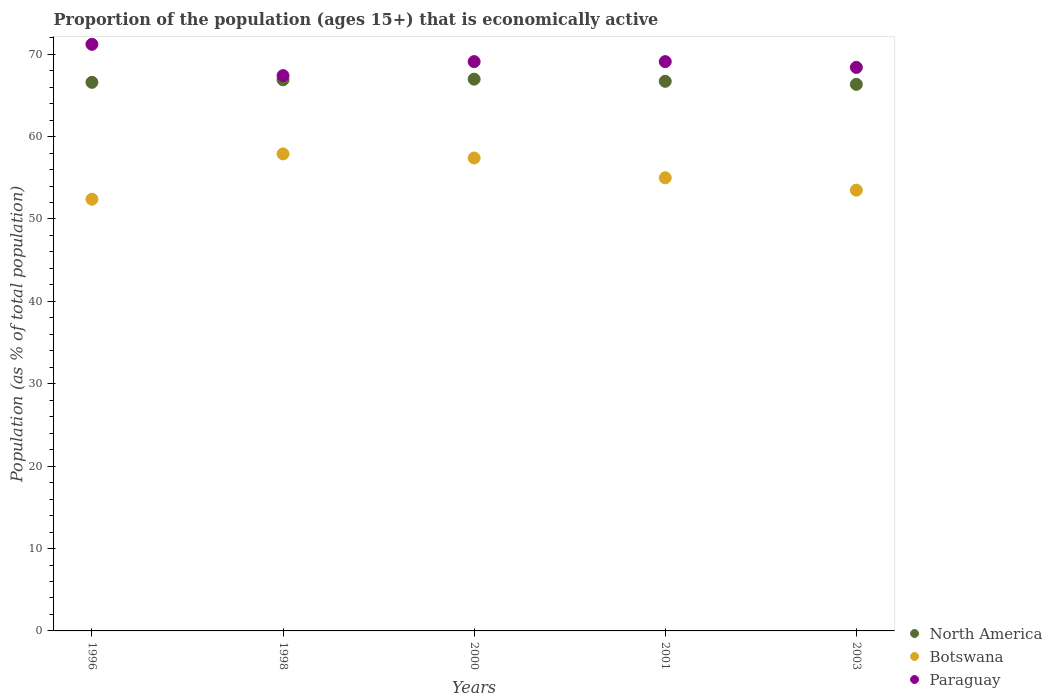What is the proportion of the population that is economically active in Paraguay in 2003?
Make the answer very short. 68.4. Across all years, what is the maximum proportion of the population that is economically active in North America?
Your answer should be very brief. 66.97. Across all years, what is the minimum proportion of the population that is economically active in North America?
Your answer should be compact. 66.34. What is the total proportion of the population that is economically active in Paraguay in the graph?
Offer a very short reply. 345.2. What is the difference between the proportion of the population that is economically active in North America in 1996 and that in 2003?
Offer a terse response. 0.25. What is the difference between the proportion of the population that is economically active in North America in 1998 and the proportion of the population that is economically active in Paraguay in 2003?
Provide a short and direct response. -1.5. What is the average proportion of the population that is economically active in Paraguay per year?
Provide a succinct answer. 69.04. In the year 2003, what is the difference between the proportion of the population that is economically active in Botswana and proportion of the population that is economically active in North America?
Ensure brevity in your answer.  -12.84. In how many years, is the proportion of the population that is economically active in Paraguay greater than 12 %?
Your response must be concise. 5. What is the ratio of the proportion of the population that is economically active in Paraguay in 1998 to that in 2003?
Your answer should be very brief. 0.99. Is the difference between the proportion of the population that is economically active in Botswana in 2001 and 2003 greater than the difference between the proportion of the population that is economically active in North America in 2001 and 2003?
Provide a short and direct response. Yes. What is the difference between the highest and the second highest proportion of the population that is economically active in Botswana?
Provide a short and direct response. 0.5. What is the difference between the highest and the lowest proportion of the population that is economically active in North America?
Provide a succinct answer. 0.63. In how many years, is the proportion of the population that is economically active in Paraguay greater than the average proportion of the population that is economically active in Paraguay taken over all years?
Offer a terse response. 3. Is the sum of the proportion of the population that is economically active in Paraguay in 1998 and 2003 greater than the maximum proportion of the population that is economically active in Botswana across all years?
Your answer should be very brief. Yes. Is it the case that in every year, the sum of the proportion of the population that is economically active in North America and proportion of the population that is economically active in Paraguay  is greater than the proportion of the population that is economically active in Botswana?
Provide a short and direct response. Yes. Does the proportion of the population that is economically active in Botswana monotonically increase over the years?
Your answer should be very brief. No. How many dotlines are there?
Your response must be concise. 3. How many years are there in the graph?
Your answer should be compact. 5. What is the difference between two consecutive major ticks on the Y-axis?
Your answer should be compact. 10. Are the values on the major ticks of Y-axis written in scientific E-notation?
Your response must be concise. No. Does the graph contain any zero values?
Make the answer very short. No. How many legend labels are there?
Offer a very short reply. 3. How are the legend labels stacked?
Your answer should be compact. Vertical. What is the title of the graph?
Ensure brevity in your answer.  Proportion of the population (ages 15+) that is economically active. Does "Mexico" appear as one of the legend labels in the graph?
Keep it short and to the point. No. What is the label or title of the X-axis?
Provide a succinct answer. Years. What is the label or title of the Y-axis?
Ensure brevity in your answer.  Population (as % of total population). What is the Population (as % of total population) in North America in 1996?
Keep it short and to the point. 66.59. What is the Population (as % of total population) of Botswana in 1996?
Provide a short and direct response. 52.4. What is the Population (as % of total population) in Paraguay in 1996?
Your answer should be very brief. 71.2. What is the Population (as % of total population) in North America in 1998?
Provide a succinct answer. 66.9. What is the Population (as % of total population) in Botswana in 1998?
Make the answer very short. 57.9. What is the Population (as % of total population) of Paraguay in 1998?
Make the answer very short. 67.4. What is the Population (as % of total population) in North America in 2000?
Your answer should be compact. 66.97. What is the Population (as % of total population) of Botswana in 2000?
Offer a very short reply. 57.4. What is the Population (as % of total population) in Paraguay in 2000?
Give a very brief answer. 69.1. What is the Population (as % of total population) of North America in 2001?
Make the answer very short. 66.71. What is the Population (as % of total population) in Botswana in 2001?
Your response must be concise. 55. What is the Population (as % of total population) in Paraguay in 2001?
Ensure brevity in your answer.  69.1. What is the Population (as % of total population) in North America in 2003?
Give a very brief answer. 66.34. What is the Population (as % of total population) of Botswana in 2003?
Make the answer very short. 53.5. What is the Population (as % of total population) in Paraguay in 2003?
Offer a very short reply. 68.4. Across all years, what is the maximum Population (as % of total population) of North America?
Provide a short and direct response. 66.97. Across all years, what is the maximum Population (as % of total population) in Botswana?
Ensure brevity in your answer.  57.9. Across all years, what is the maximum Population (as % of total population) of Paraguay?
Keep it short and to the point. 71.2. Across all years, what is the minimum Population (as % of total population) in North America?
Offer a terse response. 66.34. Across all years, what is the minimum Population (as % of total population) in Botswana?
Make the answer very short. 52.4. Across all years, what is the minimum Population (as % of total population) of Paraguay?
Your answer should be compact. 67.4. What is the total Population (as % of total population) in North America in the graph?
Your response must be concise. 333.51. What is the total Population (as % of total population) in Botswana in the graph?
Provide a succinct answer. 276.2. What is the total Population (as % of total population) in Paraguay in the graph?
Offer a terse response. 345.2. What is the difference between the Population (as % of total population) in North America in 1996 and that in 1998?
Provide a short and direct response. -0.31. What is the difference between the Population (as % of total population) in Botswana in 1996 and that in 1998?
Offer a very short reply. -5.5. What is the difference between the Population (as % of total population) in Paraguay in 1996 and that in 1998?
Provide a short and direct response. 3.8. What is the difference between the Population (as % of total population) in North America in 1996 and that in 2000?
Make the answer very short. -0.38. What is the difference between the Population (as % of total population) in Botswana in 1996 and that in 2000?
Your answer should be compact. -5. What is the difference between the Population (as % of total population) of North America in 1996 and that in 2001?
Make the answer very short. -0.12. What is the difference between the Population (as % of total population) in Botswana in 1996 and that in 2001?
Provide a succinct answer. -2.6. What is the difference between the Population (as % of total population) of North America in 1996 and that in 2003?
Your response must be concise. 0.25. What is the difference between the Population (as % of total population) of Botswana in 1996 and that in 2003?
Your answer should be very brief. -1.1. What is the difference between the Population (as % of total population) in Paraguay in 1996 and that in 2003?
Your answer should be very brief. 2.8. What is the difference between the Population (as % of total population) of North America in 1998 and that in 2000?
Offer a terse response. -0.07. What is the difference between the Population (as % of total population) in North America in 1998 and that in 2001?
Offer a terse response. 0.19. What is the difference between the Population (as % of total population) in Paraguay in 1998 and that in 2001?
Give a very brief answer. -1.7. What is the difference between the Population (as % of total population) in North America in 1998 and that in 2003?
Your response must be concise. 0.56. What is the difference between the Population (as % of total population) in Botswana in 1998 and that in 2003?
Your answer should be compact. 4.4. What is the difference between the Population (as % of total population) in Paraguay in 1998 and that in 2003?
Your answer should be compact. -1. What is the difference between the Population (as % of total population) of North America in 2000 and that in 2001?
Offer a terse response. 0.26. What is the difference between the Population (as % of total population) of Paraguay in 2000 and that in 2001?
Your answer should be very brief. 0. What is the difference between the Population (as % of total population) of North America in 2000 and that in 2003?
Give a very brief answer. 0.63. What is the difference between the Population (as % of total population) in Paraguay in 2000 and that in 2003?
Offer a very short reply. 0.7. What is the difference between the Population (as % of total population) of North America in 2001 and that in 2003?
Ensure brevity in your answer.  0.37. What is the difference between the Population (as % of total population) of North America in 1996 and the Population (as % of total population) of Botswana in 1998?
Your answer should be very brief. 8.69. What is the difference between the Population (as % of total population) in North America in 1996 and the Population (as % of total population) in Paraguay in 1998?
Make the answer very short. -0.81. What is the difference between the Population (as % of total population) in North America in 1996 and the Population (as % of total population) in Botswana in 2000?
Keep it short and to the point. 9.19. What is the difference between the Population (as % of total population) in North America in 1996 and the Population (as % of total population) in Paraguay in 2000?
Ensure brevity in your answer.  -2.51. What is the difference between the Population (as % of total population) in Botswana in 1996 and the Population (as % of total population) in Paraguay in 2000?
Keep it short and to the point. -16.7. What is the difference between the Population (as % of total population) of North America in 1996 and the Population (as % of total population) of Botswana in 2001?
Provide a short and direct response. 11.59. What is the difference between the Population (as % of total population) in North America in 1996 and the Population (as % of total population) in Paraguay in 2001?
Keep it short and to the point. -2.51. What is the difference between the Population (as % of total population) of Botswana in 1996 and the Population (as % of total population) of Paraguay in 2001?
Make the answer very short. -16.7. What is the difference between the Population (as % of total population) of North America in 1996 and the Population (as % of total population) of Botswana in 2003?
Ensure brevity in your answer.  13.09. What is the difference between the Population (as % of total population) in North America in 1996 and the Population (as % of total population) in Paraguay in 2003?
Offer a terse response. -1.81. What is the difference between the Population (as % of total population) of Botswana in 1996 and the Population (as % of total population) of Paraguay in 2003?
Offer a very short reply. -16. What is the difference between the Population (as % of total population) in North America in 1998 and the Population (as % of total population) in Botswana in 2000?
Provide a succinct answer. 9.5. What is the difference between the Population (as % of total population) of North America in 1998 and the Population (as % of total population) of Paraguay in 2000?
Your answer should be very brief. -2.2. What is the difference between the Population (as % of total population) of North America in 1998 and the Population (as % of total population) of Botswana in 2001?
Make the answer very short. 11.9. What is the difference between the Population (as % of total population) of North America in 1998 and the Population (as % of total population) of Paraguay in 2001?
Offer a terse response. -2.2. What is the difference between the Population (as % of total population) of North America in 1998 and the Population (as % of total population) of Botswana in 2003?
Ensure brevity in your answer.  13.4. What is the difference between the Population (as % of total population) in North America in 1998 and the Population (as % of total population) in Paraguay in 2003?
Offer a very short reply. -1.5. What is the difference between the Population (as % of total population) of Botswana in 1998 and the Population (as % of total population) of Paraguay in 2003?
Your answer should be very brief. -10.5. What is the difference between the Population (as % of total population) in North America in 2000 and the Population (as % of total population) in Botswana in 2001?
Your response must be concise. 11.97. What is the difference between the Population (as % of total population) in North America in 2000 and the Population (as % of total population) in Paraguay in 2001?
Ensure brevity in your answer.  -2.13. What is the difference between the Population (as % of total population) of North America in 2000 and the Population (as % of total population) of Botswana in 2003?
Offer a terse response. 13.47. What is the difference between the Population (as % of total population) in North America in 2000 and the Population (as % of total population) in Paraguay in 2003?
Provide a short and direct response. -1.43. What is the difference between the Population (as % of total population) of Botswana in 2000 and the Population (as % of total population) of Paraguay in 2003?
Ensure brevity in your answer.  -11. What is the difference between the Population (as % of total population) of North America in 2001 and the Population (as % of total population) of Botswana in 2003?
Your answer should be compact. 13.21. What is the difference between the Population (as % of total population) of North America in 2001 and the Population (as % of total population) of Paraguay in 2003?
Provide a short and direct response. -1.69. What is the average Population (as % of total population) in North America per year?
Make the answer very short. 66.7. What is the average Population (as % of total population) of Botswana per year?
Make the answer very short. 55.24. What is the average Population (as % of total population) in Paraguay per year?
Your response must be concise. 69.04. In the year 1996, what is the difference between the Population (as % of total population) in North America and Population (as % of total population) in Botswana?
Offer a very short reply. 14.19. In the year 1996, what is the difference between the Population (as % of total population) in North America and Population (as % of total population) in Paraguay?
Your response must be concise. -4.61. In the year 1996, what is the difference between the Population (as % of total population) in Botswana and Population (as % of total population) in Paraguay?
Your answer should be very brief. -18.8. In the year 1998, what is the difference between the Population (as % of total population) of North America and Population (as % of total population) of Botswana?
Your answer should be very brief. 9. In the year 1998, what is the difference between the Population (as % of total population) of North America and Population (as % of total population) of Paraguay?
Give a very brief answer. -0.5. In the year 2000, what is the difference between the Population (as % of total population) of North America and Population (as % of total population) of Botswana?
Your response must be concise. 9.57. In the year 2000, what is the difference between the Population (as % of total population) in North America and Population (as % of total population) in Paraguay?
Give a very brief answer. -2.13. In the year 2001, what is the difference between the Population (as % of total population) in North America and Population (as % of total population) in Botswana?
Keep it short and to the point. 11.71. In the year 2001, what is the difference between the Population (as % of total population) in North America and Population (as % of total population) in Paraguay?
Your answer should be compact. -2.39. In the year 2001, what is the difference between the Population (as % of total population) in Botswana and Population (as % of total population) in Paraguay?
Your answer should be very brief. -14.1. In the year 2003, what is the difference between the Population (as % of total population) in North America and Population (as % of total population) in Botswana?
Your answer should be very brief. 12.84. In the year 2003, what is the difference between the Population (as % of total population) in North America and Population (as % of total population) in Paraguay?
Provide a succinct answer. -2.06. In the year 2003, what is the difference between the Population (as % of total population) of Botswana and Population (as % of total population) of Paraguay?
Offer a terse response. -14.9. What is the ratio of the Population (as % of total population) of North America in 1996 to that in 1998?
Make the answer very short. 1. What is the ratio of the Population (as % of total population) in Botswana in 1996 to that in 1998?
Provide a short and direct response. 0.91. What is the ratio of the Population (as % of total population) in Paraguay in 1996 to that in 1998?
Offer a terse response. 1.06. What is the ratio of the Population (as % of total population) in Botswana in 1996 to that in 2000?
Give a very brief answer. 0.91. What is the ratio of the Population (as % of total population) in Paraguay in 1996 to that in 2000?
Offer a very short reply. 1.03. What is the ratio of the Population (as % of total population) of North America in 1996 to that in 2001?
Your response must be concise. 1. What is the ratio of the Population (as % of total population) in Botswana in 1996 to that in 2001?
Offer a very short reply. 0.95. What is the ratio of the Population (as % of total population) in Paraguay in 1996 to that in 2001?
Your response must be concise. 1.03. What is the ratio of the Population (as % of total population) of Botswana in 1996 to that in 2003?
Provide a short and direct response. 0.98. What is the ratio of the Population (as % of total population) in Paraguay in 1996 to that in 2003?
Your answer should be compact. 1.04. What is the ratio of the Population (as % of total population) of Botswana in 1998 to that in 2000?
Your answer should be compact. 1.01. What is the ratio of the Population (as % of total population) of Paraguay in 1998 to that in 2000?
Make the answer very short. 0.98. What is the ratio of the Population (as % of total population) of Botswana in 1998 to that in 2001?
Ensure brevity in your answer.  1.05. What is the ratio of the Population (as % of total population) in Paraguay in 1998 to that in 2001?
Give a very brief answer. 0.98. What is the ratio of the Population (as % of total population) of North America in 1998 to that in 2003?
Make the answer very short. 1.01. What is the ratio of the Population (as % of total population) in Botswana in 1998 to that in 2003?
Provide a succinct answer. 1.08. What is the ratio of the Population (as % of total population) of Paraguay in 1998 to that in 2003?
Offer a terse response. 0.99. What is the ratio of the Population (as % of total population) in North America in 2000 to that in 2001?
Provide a succinct answer. 1. What is the ratio of the Population (as % of total population) in Botswana in 2000 to that in 2001?
Your answer should be compact. 1.04. What is the ratio of the Population (as % of total population) of North America in 2000 to that in 2003?
Ensure brevity in your answer.  1.01. What is the ratio of the Population (as % of total population) of Botswana in 2000 to that in 2003?
Offer a very short reply. 1.07. What is the ratio of the Population (as % of total population) of Paraguay in 2000 to that in 2003?
Your answer should be very brief. 1.01. What is the ratio of the Population (as % of total population) in Botswana in 2001 to that in 2003?
Make the answer very short. 1.03. What is the ratio of the Population (as % of total population) of Paraguay in 2001 to that in 2003?
Give a very brief answer. 1.01. What is the difference between the highest and the second highest Population (as % of total population) in North America?
Your answer should be compact. 0.07. What is the difference between the highest and the second highest Population (as % of total population) in Paraguay?
Provide a short and direct response. 2.1. What is the difference between the highest and the lowest Population (as % of total population) of North America?
Give a very brief answer. 0.63. What is the difference between the highest and the lowest Population (as % of total population) in Paraguay?
Provide a succinct answer. 3.8. 